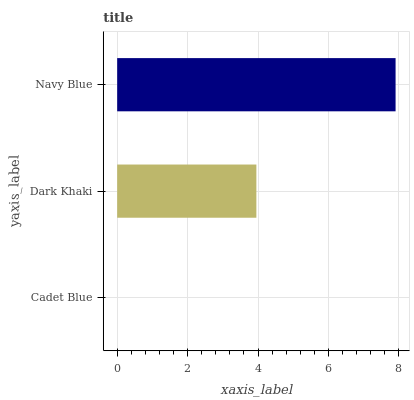Is Cadet Blue the minimum?
Answer yes or no. Yes. Is Navy Blue the maximum?
Answer yes or no. Yes. Is Dark Khaki the minimum?
Answer yes or no. No. Is Dark Khaki the maximum?
Answer yes or no. No. Is Dark Khaki greater than Cadet Blue?
Answer yes or no. Yes. Is Cadet Blue less than Dark Khaki?
Answer yes or no. Yes. Is Cadet Blue greater than Dark Khaki?
Answer yes or no. No. Is Dark Khaki less than Cadet Blue?
Answer yes or no. No. Is Dark Khaki the high median?
Answer yes or no. Yes. Is Dark Khaki the low median?
Answer yes or no. Yes. Is Navy Blue the high median?
Answer yes or no. No. Is Cadet Blue the low median?
Answer yes or no. No. 